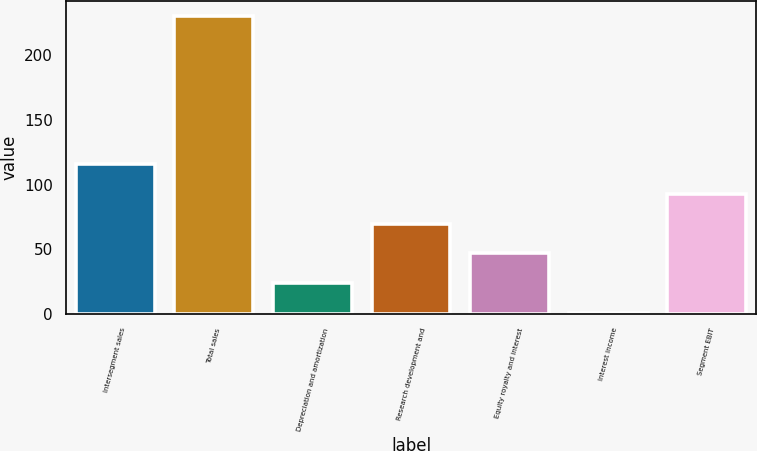Convert chart. <chart><loc_0><loc_0><loc_500><loc_500><bar_chart><fcel>Intersegment sales<fcel>Total sales<fcel>Depreciation and amortization<fcel>Research development and<fcel>Equity royalty and interest<fcel>Interest income<fcel>Segment EBIT<nl><fcel>115.5<fcel>230<fcel>23.9<fcel>69.7<fcel>46.8<fcel>1<fcel>92.6<nl></chart> 